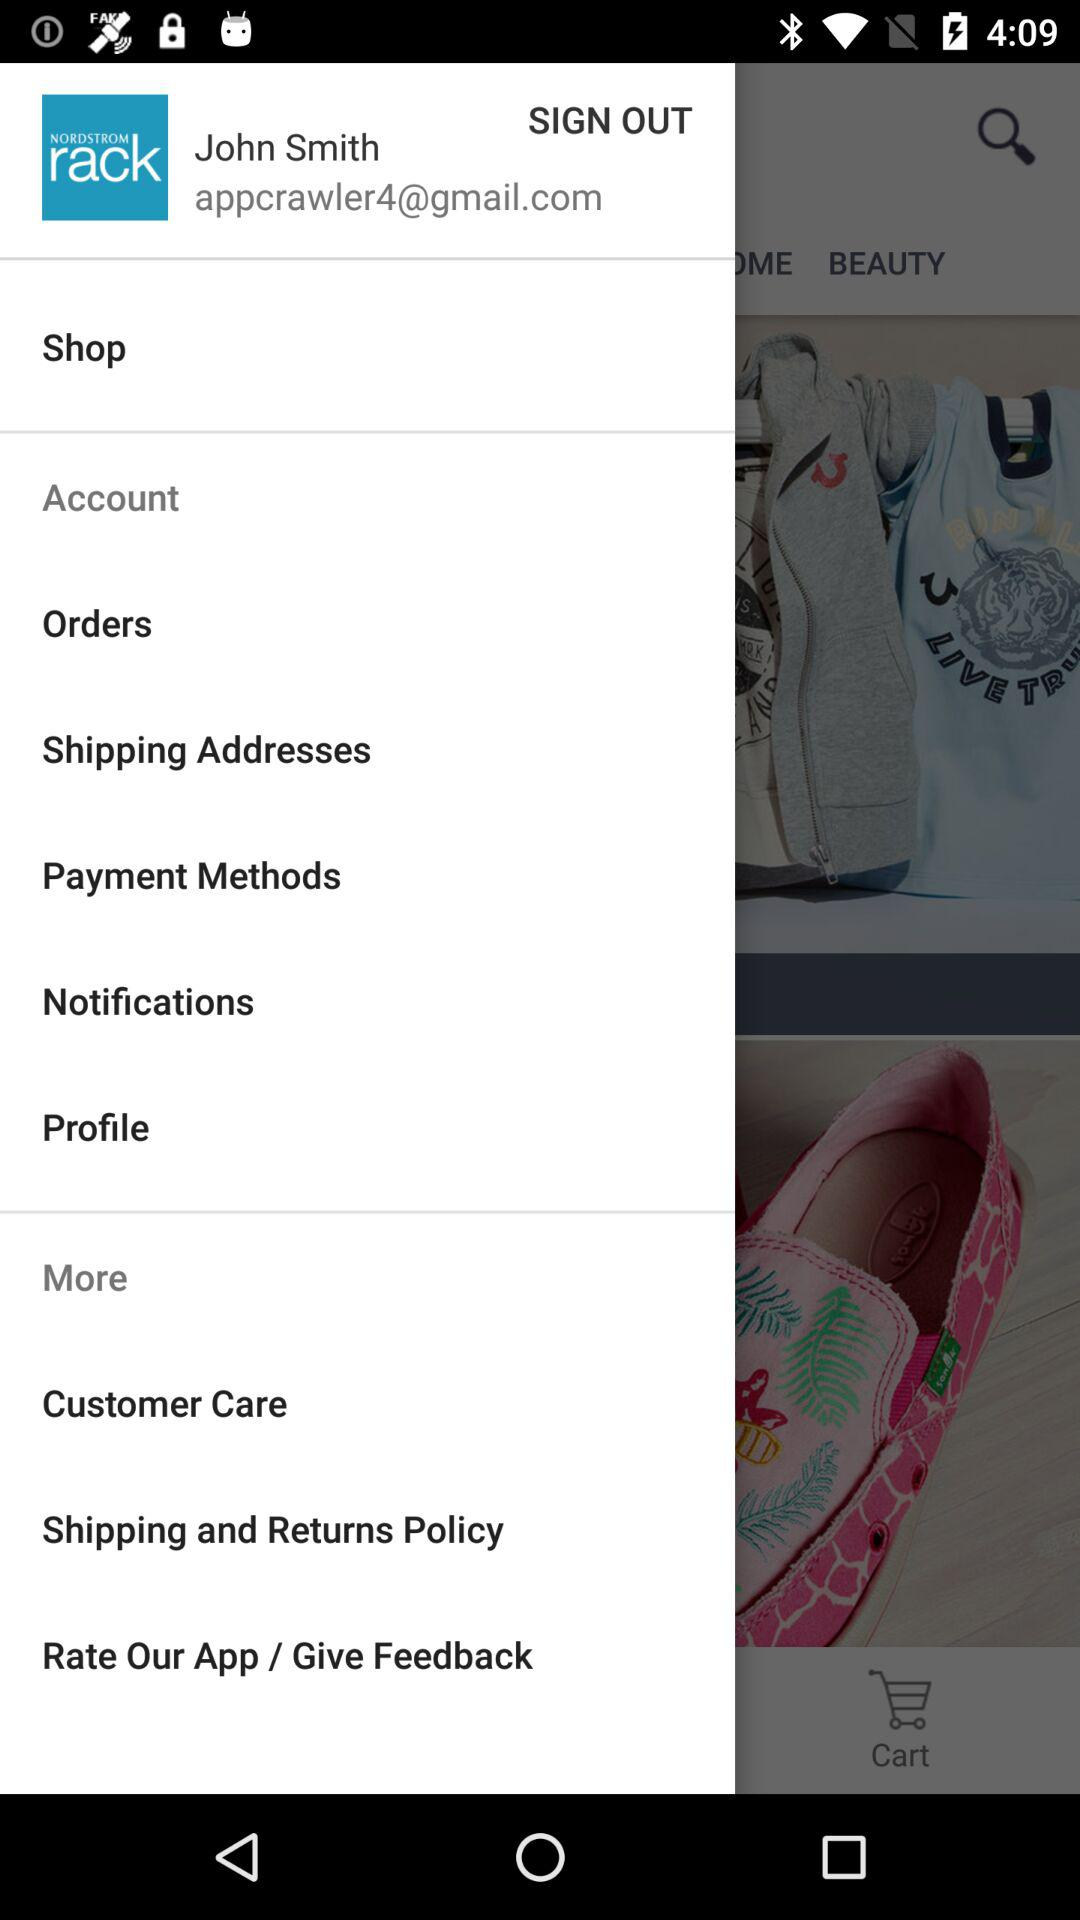What is the email address mentioned? The mentioned email address is "appcrawler4@gmail.com". 